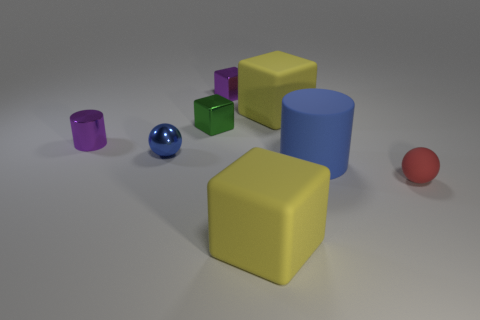What number of other things are there of the same material as the red thing
Offer a very short reply. 3. How big is the purple thing that is on the right side of the small blue shiny ball?
Ensure brevity in your answer.  Small. Is the color of the rubber sphere the same as the tiny metal cylinder?
Your answer should be very brief. No. What number of tiny objects are purple metallic objects or yellow matte blocks?
Your response must be concise. 2. Is there any other thing of the same color as the small matte sphere?
Give a very brief answer. No. Are there any large yellow things in front of the tiny purple cylinder?
Provide a succinct answer. Yes. There is a yellow cube that is behind the big yellow matte object in front of the blue cylinder; how big is it?
Keep it short and to the point. Large. Is the number of objects that are right of the large blue thing the same as the number of small metal blocks left of the small blue metal object?
Make the answer very short. No. Are there any shiny blocks in front of the yellow cube that is in front of the tiny cylinder?
Offer a terse response. No. There is a large yellow object behind the matte cube in front of the red matte sphere; what number of purple metallic objects are on the right side of it?
Offer a terse response. 0. 